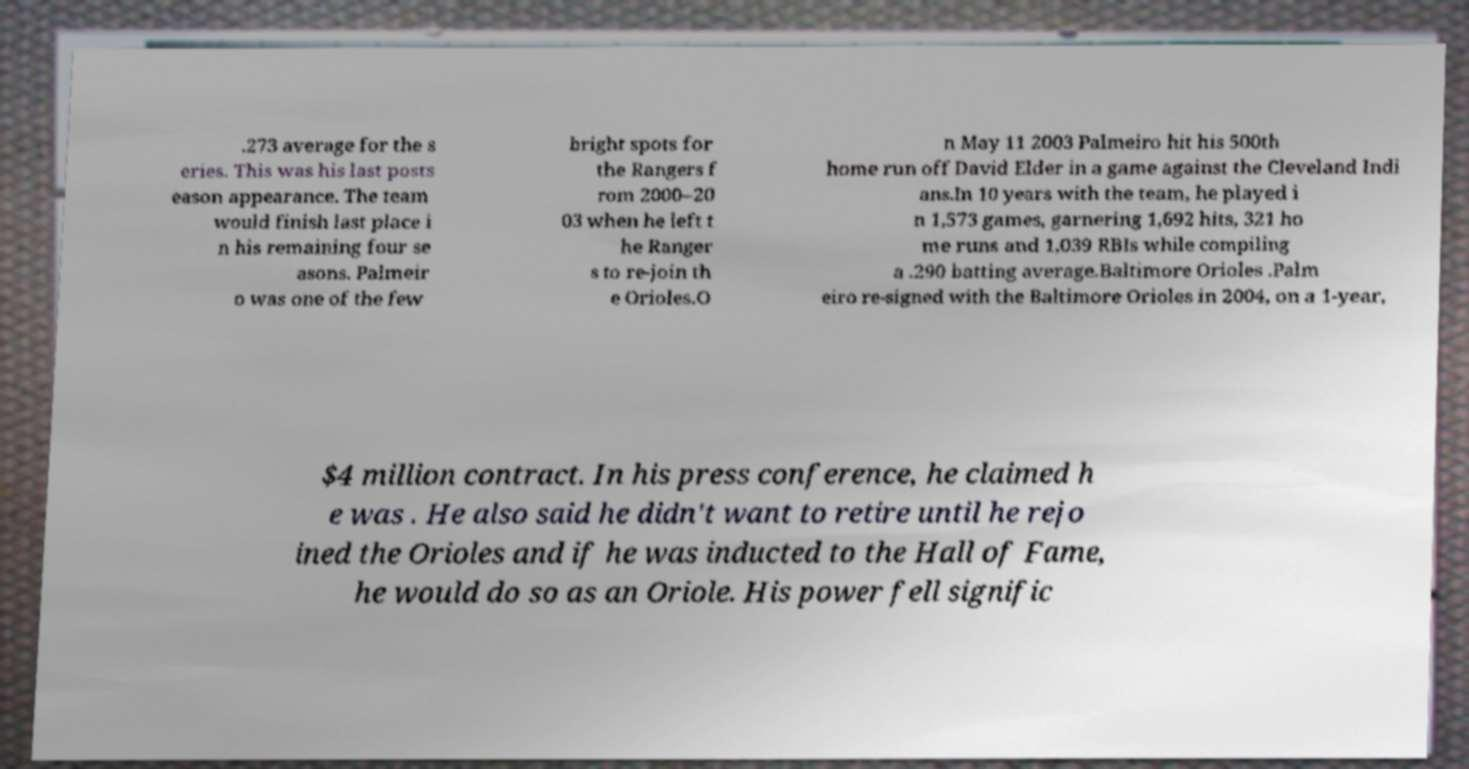Can you accurately transcribe the text from the provided image for me? .273 average for the s eries. This was his last posts eason appearance. The team would finish last place i n his remaining four se asons. Palmeir o was one of the few bright spots for the Rangers f rom 2000–20 03 when he left t he Ranger s to re-join th e Orioles.O n May 11 2003 Palmeiro hit his 500th home run off David Elder in a game against the Cleveland Indi ans.In 10 years with the team, he played i n 1,573 games, garnering 1,692 hits, 321 ho me runs and 1,039 RBIs while compiling a .290 batting average.Baltimore Orioles .Palm eiro re-signed with the Baltimore Orioles in 2004, on a 1-year, $4 million contract. In his press conference, he claimed h e was . He also said he didn't want to retire until he rejo ined the Orioles and if he was inducted to the Hall of Fame, he would do so as an Oriole. His power fell signific 